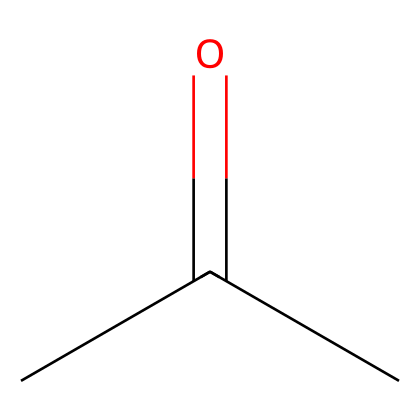What is the name of this chemical? The SMILES representation indicates a simple ketone structure with a carbonyl group (C=O) and two alkyl groups (in this case, methyl groups). Therefore, this compound is known as acetone.
Answer: acetone How many carbon atoms are present in the molecule? The SMILES shows "CC(=O)C," which indicates three carbon atoms in total; two from the "CC" and one from the "C" after the carbonyl group.
Answer: three What type of functional group does this compound contain? The presence of a carbonyl group (C=O) in the structure means that the compound is classified as a ketone, which is characterized by having a carbonyl carbon bonded to two other carbon atoms.
Answer: ketone How many hydrogen atoms are in acetone? Each carbon in acetone will form a certain number of bonds: the central carbon connected with a double bond to the oxygen does not have hydrogens attached but the two terminal methyl groups each provide three hydrogens. Thus, there are six hydrogens in total.
Answer: six What is the general use of acetone in art restoration? Acetone is commonly utilized as a solvent in paint removal and restoration processes due to its ability to dissolve various types of paint and coatings effectively without excessive residue.
Answer: paint removal and restoration How does the molecular structure affect its solvent properties? Acetone's polar nature, derived from its carbonyl group, allows it to interact with polar and nonpolar substances, which enhances its effectiveness as a solvent for a broad range of materials.
Answer: polar nature What state is acetone typically found in at room temperature? Acetone is a clear liquid at room temperature, which makes it easy to use in applications such as paint thinning and cleaning.
Answer: liquid 